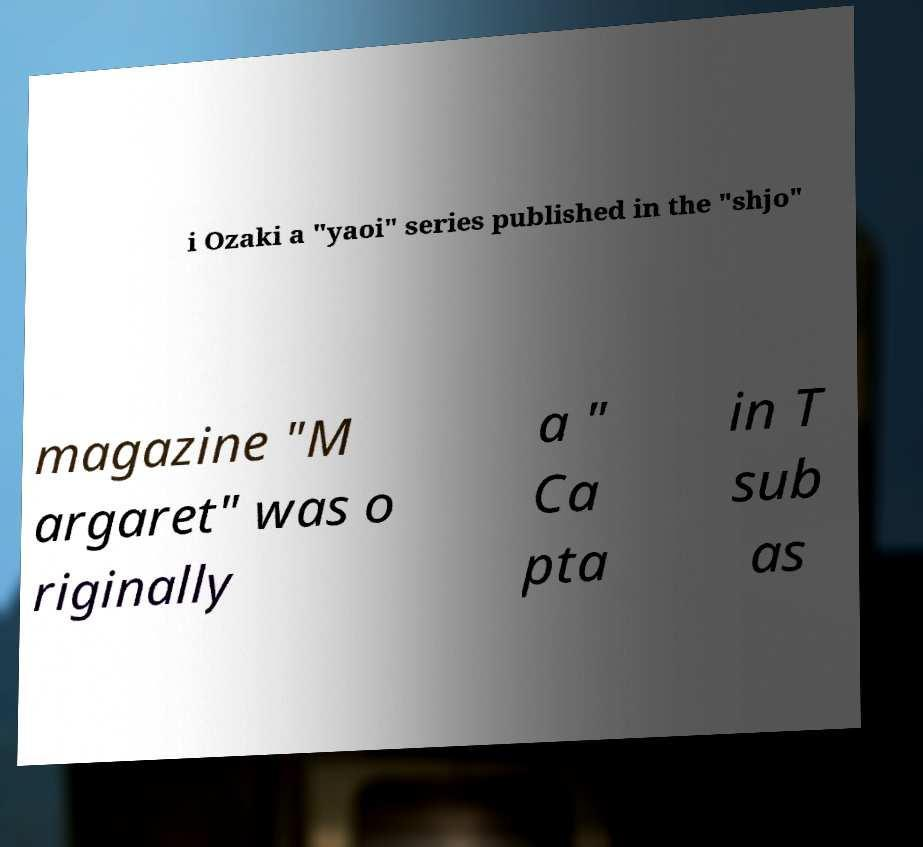There's text embedded in this image that I need extracted. Can you transcribe it verbatim? i Ozaki a "yaoi" series published in the "shjo" magazine "M argaret" was o riginally a " Ca pta in T sub as 